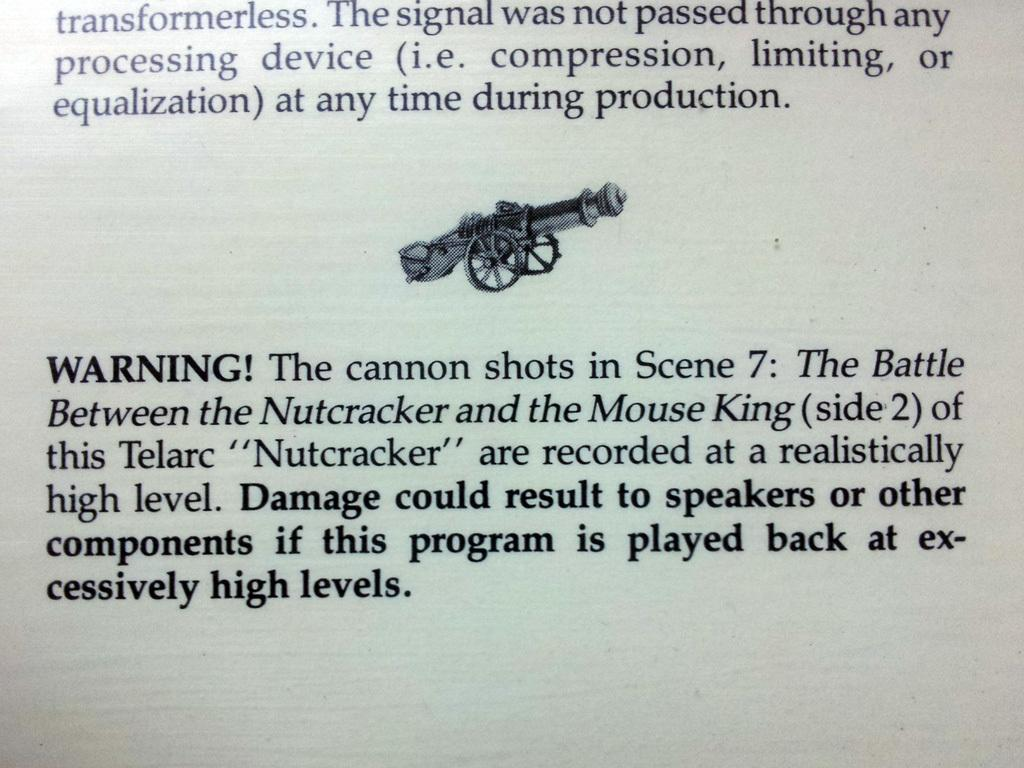What is the main subject of the black and white picture in the image? The main subject of the black and white picture in the image is a cannon. What can be observed in addition to the cannon in the image? There is text present in the image. How many cats are talking to each other in the image? There are no cats present in the image, and therefore no talking cats can be observed. 